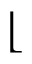Convert formula to latex. <formula><loc_0><loc_0><loc_500><loc_500>\lfloor</formula> 